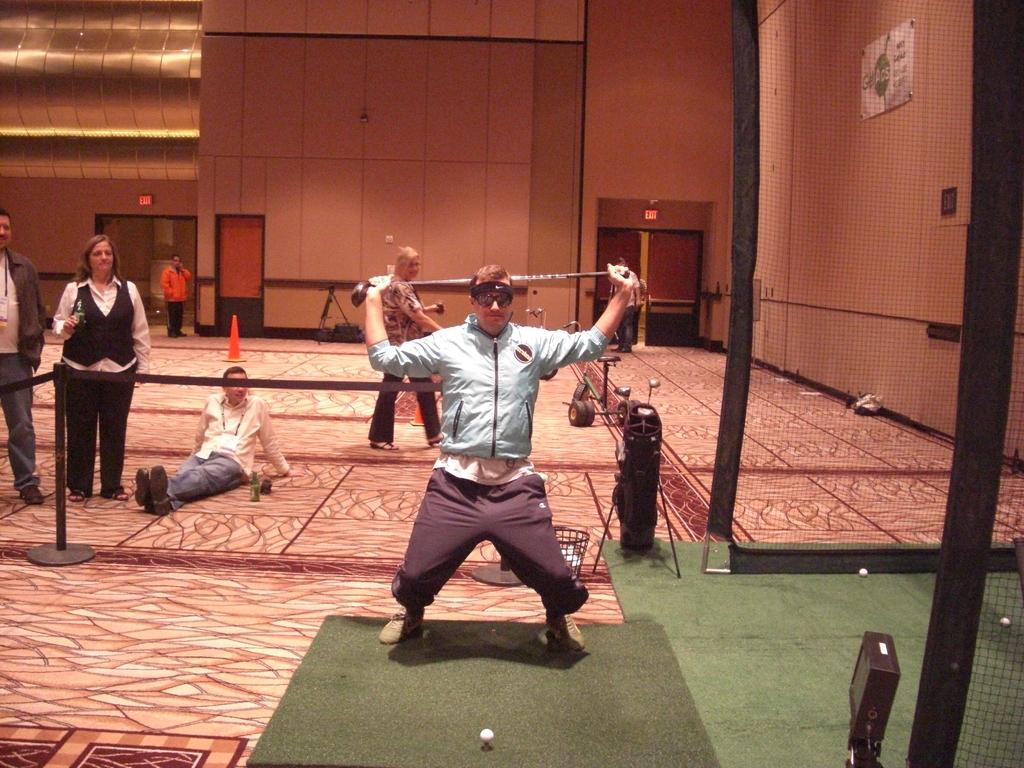What is the main subject of the image? There is a person in the image. What is the person holding in the image? The person is holding something. Can you describe the background of the image? There are other people in the background of the image. What type of structure can be seen in the image? There is fencing in the image. What other object is present in the image? There is a traffic cone in the image. Reasoning: Let' Let's think step by step in order to produce the conversation. We start by identifying the main subject of the image, which is the person. Then, we describe what the person is holding, as it is mentioned in the facts. Next, we expand the conversation to include the background of the image, noting the presence of other people. We then describe the fencing and traffic cone, which are also mentioned in the facts. Absurd Question/Answer: What time is displayed on the clock in the image? There is no clock present in the image. What type of toys can be seen in the image? There are no toys visible in the image. 